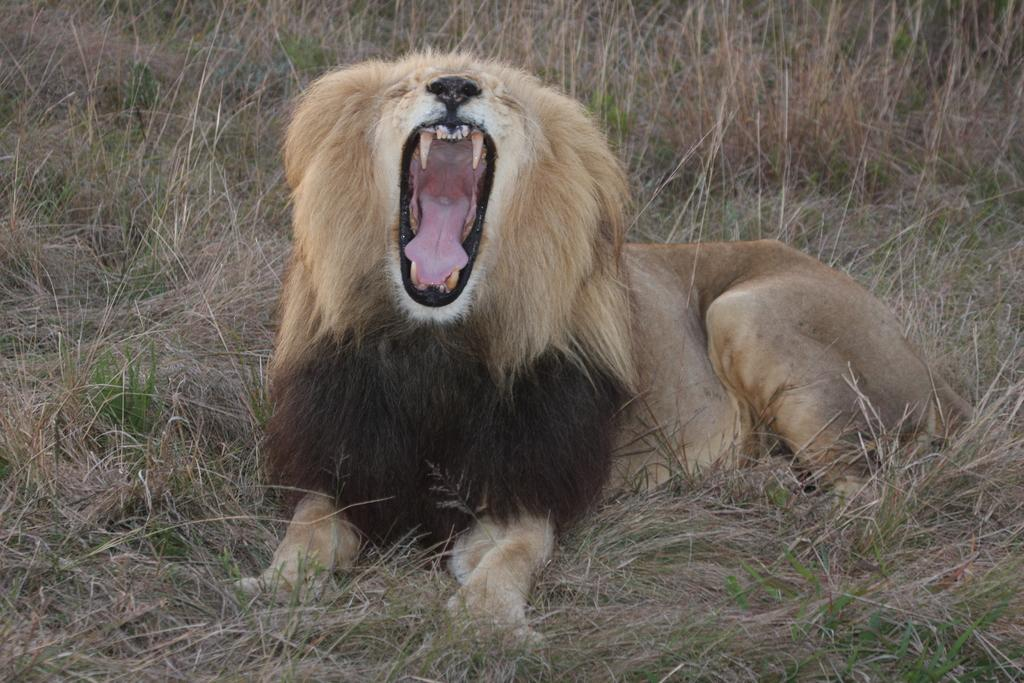What animal is the main subject of the picture? There is a lion in the picture. What is the lion doing in the image? The lion is sitting on the grass. What type of vegetation can be seen in the image? There is green grass visible in the image. Can you see any snails swimming in the grass in the image? There are no snails or swimming activity visible in the image; it features a lion sitting on green grass. 